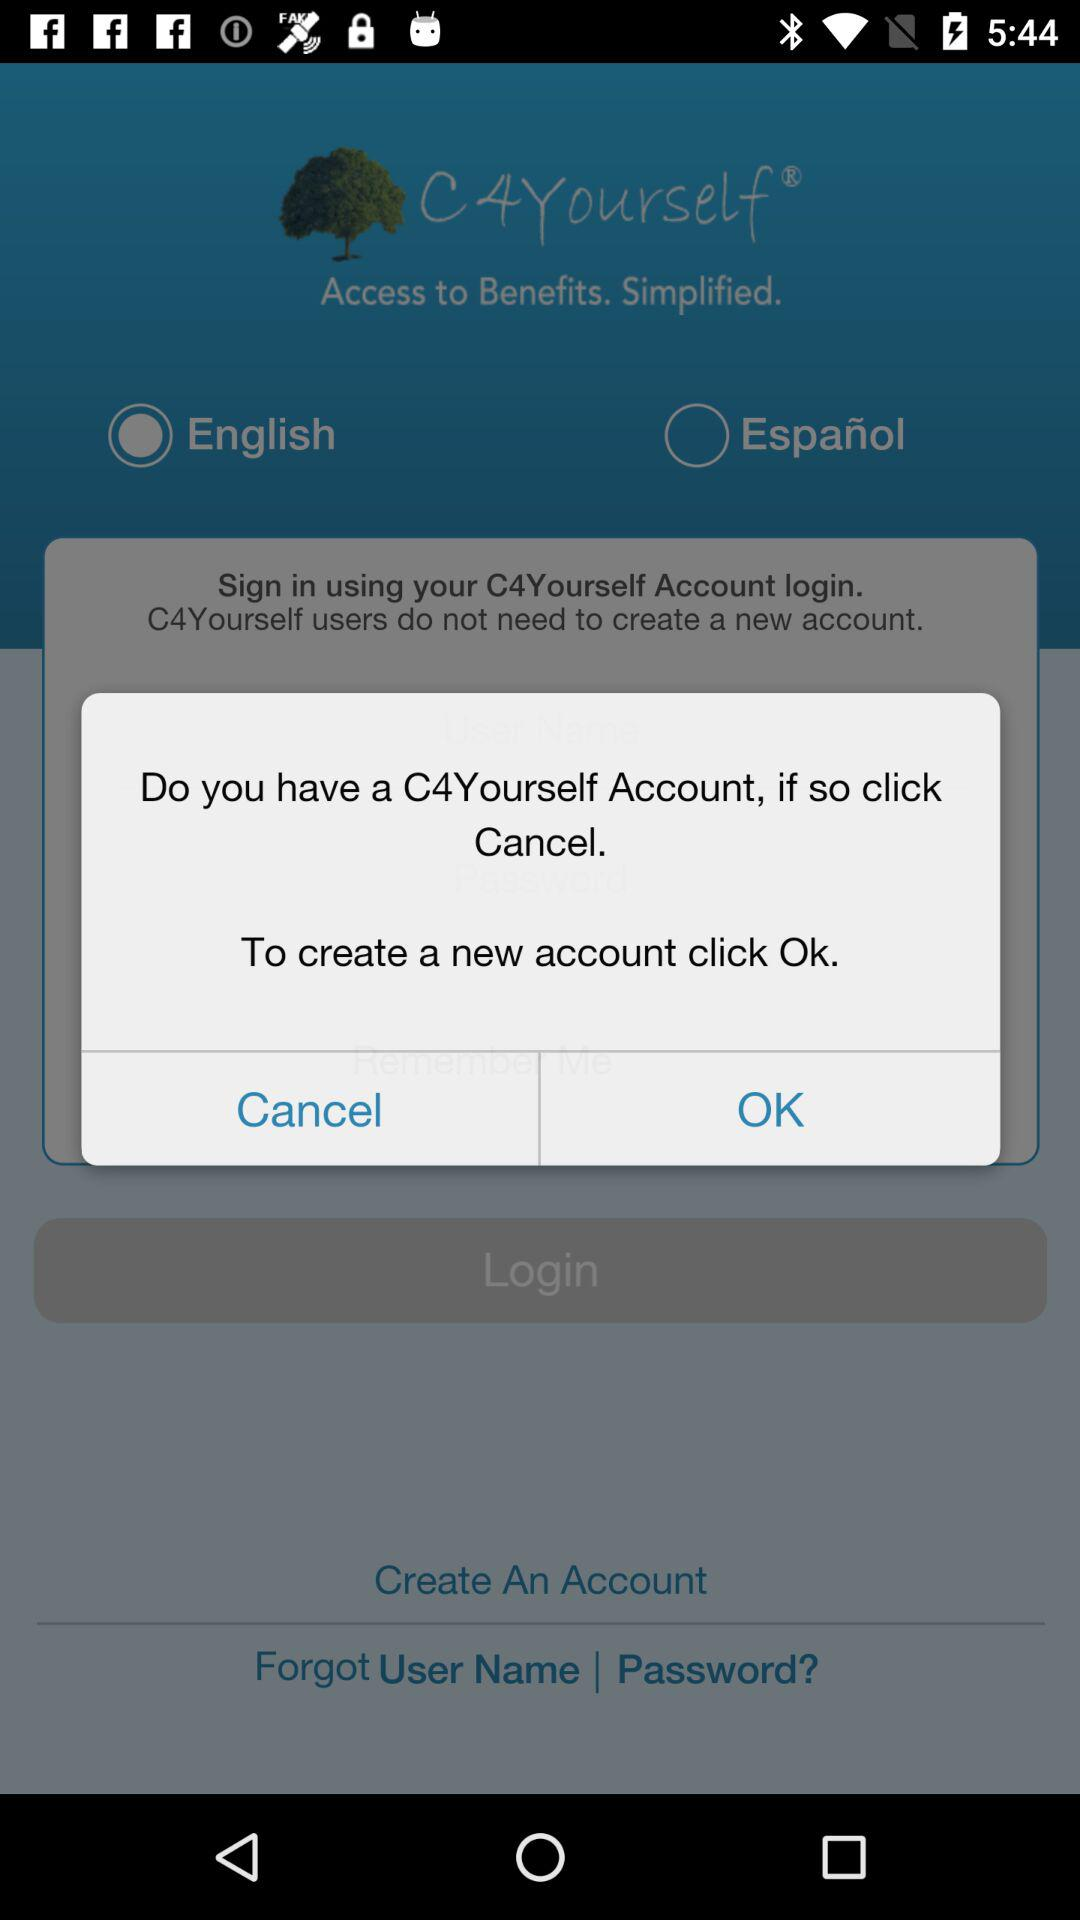What is the name of the application? The name of the application is "C4Yourself". 